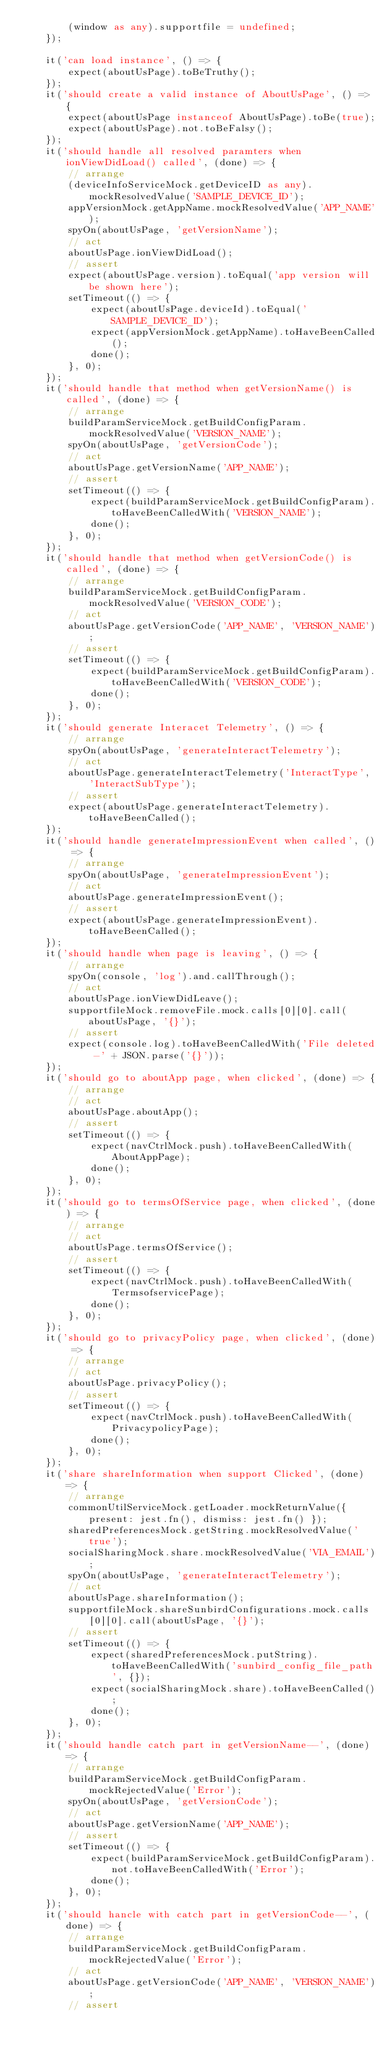Convert code to text. <code><loc_0><loc_0><loc_500><loc_500><_TypeScript_>        (window as any).supportfile = undefined;
    });

    it('can load instance', () => {
        expect(aboutUsPage).toBeTruthy();
    });
    it('should create a valid instance of AboutUsPage', () => {
        expect(aboutUsPage instanceof AboutUsPage).toBe(true);
        expect(aboutUsPage).not.toBeFalsy();
    });
    it('should handle all resolved paramters when ionViewDidLoad() called', (done) => {
        // arrange
        (deviceInfoServiceMock.getDeviceID as any).mockResolvedValue('SAMPLE_DEVICE_ID');
        appVersionMock.getAppName.mockResolvedValue('APP_NAME');
        spyOn(aboutUsPage, 'getVersionName');
        // act
        aboutUsPage.ionViewDidLoad();
        // assert
        expect(aboutUsPage.version).toEqual('app version will be shown here');
        setTimeout(() => {
            expect(aboutUsPage.deviceId).toEqual('SAMPLE_DEVICE_ID');
            expect(appVersionMock.getAppName).toHaveBeenCalled();
            done();
        }, 0);
    });
    it('should handle that method when getVersionName() is called', (done) => {
        // arrange
        buildParamServiceMock.getBuildConfigParam.mockResolvedValue('VERSION_NAME');
        spyOn(aboutUsPage, 'getVersionCode');
        // act
        aboutUsPage.getVersionName('APP_NAME');
        // assert
        setTimeout(() => {
            expect(buildParamServiceMock.getBuildConfigParam).toHaveBeenCalledWith('VERSION_NAME');
            done();
        }, 0);
    });
    it('should handle that method when getVersionCode() is called', (done) => {
        // arrange
        buildParamServiceMock.getBuildConfigParam.mockResolvedValue('VERSION_CODE');
        // act
        aboutUsPage.getVersionCode('APP_NAME', 'VERSION_NAME');
        // assert
        setTimeout(() => {
            expect(buildParamServiceMock.getBuildConfigParam).toHaveBeenCalledWith('VERSION_CODE');
            done();
        }, 0);
    });
    it('should generate Interacet Telemetry', () => {
        // arrange
        spyOn(aboutUsPage, 'generateInteractTelemetry');
        // act
        aboutUsPage.generateInteractTelemetry('InteractType', 'InteractSubType');
        // assert
        expect(aboutUsPage.generateInteractTelemetry).toHaveBeenCalled();
    });
    it('should handle generateImpressionEvent when called', () => {
        // arrange
        spyOn(aboutUsPage, 'generateImpressionEvent');
        // act
        aboutUsPage.generateImpressionEvent();
        // assert
        expect(aboutUsPage.generateImpressionEvent).toHaveBeenCalled();
    });
    it('should handle when page is leaving', () => {
        // arrange
        spyOn(console, 'log').and.callThrough();
        // act
        aboutUsPage.ionViewDidLeave();
        supportfileMock.removeFile.mock.calls[0][0].call(aboutUsPage, '{}');
        // assert
        expect(console.log).toHaveBeenCalledWith('File deleted -' + JSON.parse('{}'));
    });
    it('should go to aboutApp page, when clicked', (done) => {
        // arrange
        // act
        aboutUsPage.aboutApp();
        // assert
        setTimeout(() => {
            expect(navCtrlMock.push).toHaveBeenCalledWith(AboutAppPage);
            done();
        }, 0);
    });
    it('should go to termsOfService page, when clicked', (done) => {
        // arrange
        // act
        aboutUsPage.termsOfService();
        // assert
        setTimeout(() => {
            expect(navCtrlMock.push).toHaveBeenCalledWith(TermsofservicePage);
            done();
        }, 0);
    });
    it('should go to privacyPolicy page, when clicked', (done) => {
        // arrange
        // act
        aboutUsPage.privacyPolicy();
        // assert
        setTimeout(() => {
            expect(navCtrlMock.push).toHaveBeenCalledWith(PrivacypolicyPage);
            done();
        }, 0);
    });
    it('share shareInformation when support Clicked', (done) => {
        // arrange
        commonUtilServiceMock.getLoader.mockReturnValue({ present: jest.fn(), dismiss: jest.fn() });
        sharedPreferencesMock.getString.mockResolvedValue('true');
        socialSharingMock.share.mockResolvedValue('VIA_EMAIL');
        spyOn(aboutUsPage, 'generateInteractTelemetry');
        // act
        aboutUsPage.shareInformation();
        supportfileMock.shareSunbirdConfigurations.mock.calls[0][0].call(aboutUsPage, '{}');
        // assert
        setTimeout(() => {
            expect(sharedPreferencesMock.putString).toHaveBeenCalledWith('sunbird_config_file_path', {});
            expect(socialSharingMock.share).toHaveBeenCalled();
            done();
        }, 0);
    });
    it('should handle catch part in getVersionName--', (done) => {
        // arrange
        buildParamServiceMock.getBuildConfigParam.mockRejectedValue('Error');
        spyOn(aboutUsPage, 'getVersionCode');
        // act
        aboutUsPage.getVersionName('APP_NAME');
        // assert
        setTimeout(() => {
            expect(buildParamServiceMock.getBuildConfigParam).not.toHaveBeenCalledWith('Error');
            done();
        }, 0);
    });
    it('should hancle with catch part in getVersionCode--', (done) => {
        // arrange
        buildParamServiceMock.getBuildConfigParam.mockRejectedValue('Error');
        // act
        aboutUsPage.getVersionCode('APP_NAME', 'VERSION_NAME');
        // assert</code> 